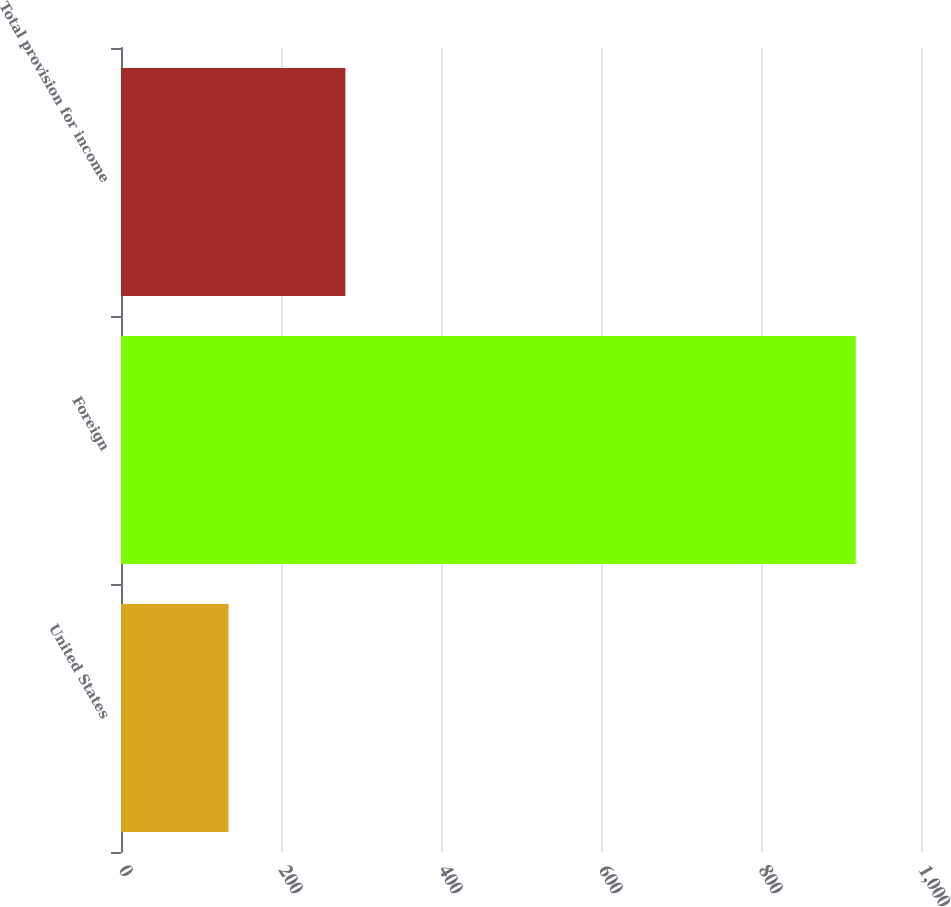Convert chart to OTSL. <chart><loc_0><loc_0><loc_500><loc_500><bar_chart><fcel>United States<fcel>Foreign<fcel>Total provision for income<nl><fcel>134.4<fcel>918.4<fcel>280.5<nl></chart> 